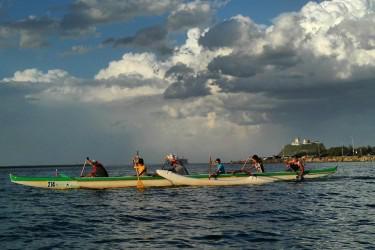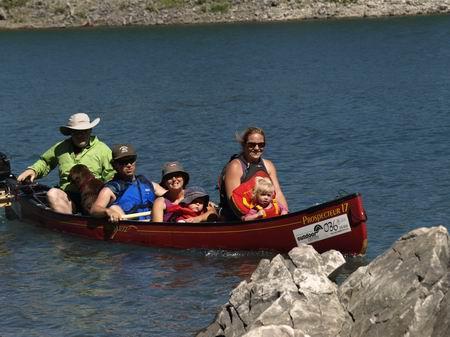The first image is the image on the left, the second image is the image on the right. For the images shown, is this caption "An image shows one boat with at least four aboard going to the right." true? Answer yes or no. Yes. The first image is the image on the left, the second image is the image on the right. Examine the images to the left and right. Is the description "There are two vessels in the water in one of the images." accurate? Answer yes or no. Yes. 